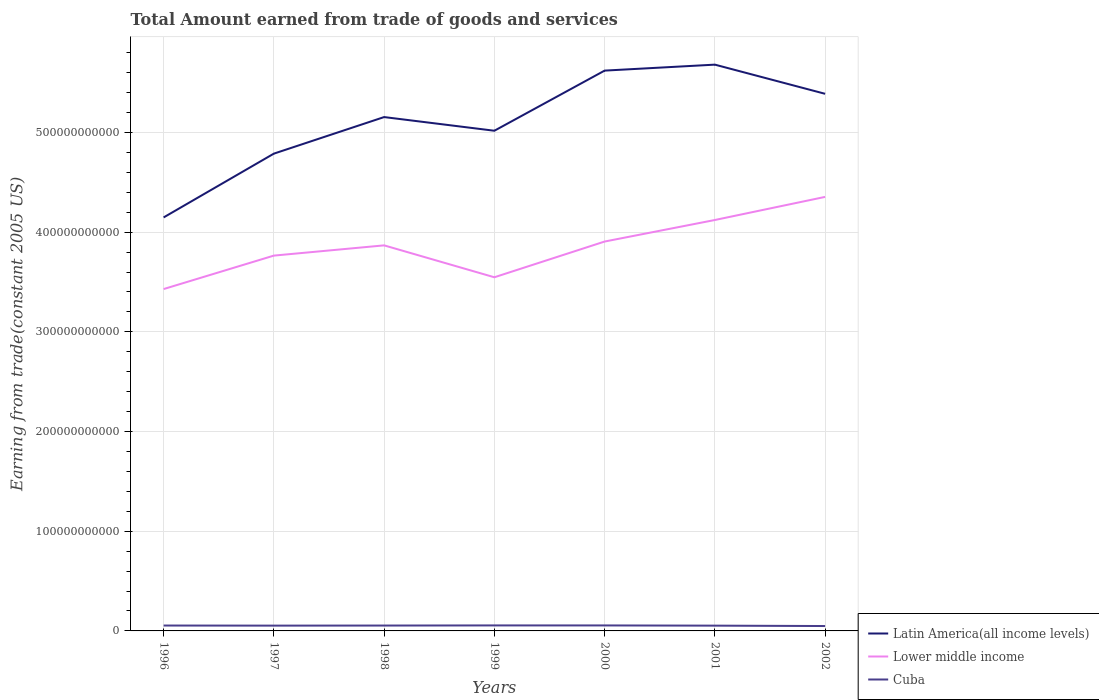How many different coloured lines are there?
Provide a succinct answer. 3. Does the line corresponding to Lower middle income intersect with the line corresponding to Cuba?
Keep it short and to the point. No. Is the number of lines equal to the number of legend labels?
Your answer should be very brief. Yes. Across all years, what is the maximum total amount earned by trading goods and services in Cuba?
Your answer should be compact. 4.91e+09. In which year was the total amount earned by trading goods and services in Lower middle income maximum?
Offer a very short reply. 1996. What is the total total amount earned by trading goods and services in Cuba in the graph?
Provide a short and direct response. 5.93e+08. What is the difference between the highest and the second highest total amount earned by trading goods and services in Lower middle income?
Your answer should be very brief. 9.25e+1. How many lines are there?
Provide a succinct answer. 3. How many years are there in the graph?
Provide a short and direct response. 7. What is the difference between two consecutive major ticks on the Y-axis?
Provide a succinct answer. 1.00e+11. Are the values on the major ticks of Y-axis written in scientific E-notation?
Provide a short and direct response. No. Does the graph contain grids?
Provide a short and direct response. Yes. Where does the legend appear in the graph?
Your answer should be very brief. Bottom right. How many legend labels are there?
Your answer should be compact. 3. How are the legend labels stacked?
Your answer should be compact. Vertical. What is the title of the graph?
Your response must be concise. Total Amount earned from trade of goods and services. What is the label or title of the Y-axis?
Your response must be concise. Earning from trade(constant 2005 US). What is the Earning from trade(constant 2005 US) of Latin America(all income levels) in 1996?
Your response must be concise. 4.15e+11. What is the Earning from trade(constant 2005 US) in Lower middle income in 1996?
Provide a short and direct response. 3.43e+11. What is the Earning from trade(constant 2005 US) in Cuba in 1996?
Offer a terse response. 5.41e+09. What is the Earning from trade(constant 2005 US) of Latin America(all income levels) in 1997?
Offer a terse response. 4.79e+11. What is the Earning from trade(constant 2005 US) of Lower middle income in 1997?
Give a very brief answer. 3.76e+11. What is the Earning from trade(constant 2005 US) of Cuba in 1997?
Give a very brief answer. 5.31e+09. What is the Earning from trade(constant 2005 US) of Latin America(all income levels) in 1998?
Make the answer very short. 5.15e+11. What is the Earning from trade(constant 2005 US) in Lower middle income in 1998?
Your answer should be compact. 3.87e+11. What is the Earning from trade(constant 2005 US) in Cuba in 1998?
Offer a very short reply. 5.38e+09. What is the Earning from trade(constant 2005 US) in Latin America(all income levels) in 1999?
Your answer should be compact. 5.02e+11. What is the Earning from trade(constant 2005 US) in Lower middle income in 1999?
Offer a very short reply. 3.55e+11. What is the Earning from trade(constant 2005 US) of Cuba in 1999?
Your answer should be compact. 5.52e+09. What is the Earning from trade(constant 2005 US) of Latin America(all income levels) in 2000?
Keep it short and to the point. 5.62e+11. What is the Earning from trade(constant 2005 US) of Lower middle income in 2000?
Your answer should be very brief. 3.91e+11. What is the Earning from trade(constant 2005 US) in Cuba in 2000?
Offer a very short reply. 5.50e+09. What is the Earning from trade(constant 2005 US) in Latin America(all income levels) in 2001?
Provide a short and direct response. 5.68e+11. What is the Earning from trade(constant 2005 US) of Lower middle income in 2001?
Keep it short and to the point. 4.12e+11. What is the Earning from trade(constant 2005 US) of Cuba in 2001?
Your answer should be very brief. 5.30e+09. What is the Earning from trade(constant 2005 US) of Latin America(all income levels) in 2002?
Your answer should be compact. 5.39e+11. What is the Earning from trade(constant 2005 US) of Lower middle income in 2002?
Ensure brevity in your answer.  4.35e+11. What is the Earning from trade(constant 2005 US) in Cuba in 2002?
Offer a very short reply. 4.91e+09. Across all years, what is the maximum Earning from trade(constant 2005 US) of Latin America(all income levels)?
Offer a terse response. 5.68e+11. Across all years, what is the maximum Earning from trade(constant 2005 US) in Lower middle income?
Provide a short and direct response. 4.35e+11. Across all years, what is the maximum Earning from trade(constant 2005 US) of Cuba?
Make the answer very short. 5.52e+09. Across all years, what is the minimum Earning from trade(constant 2005 US) in Latin America(all income levels)?
Provide a succinct answer. 4.15e+11. Across all years, what is the minimum Earning from trade(constant 2005 US) of Lower middle income?
Make the answer very short. 3.43e+11. Across all years, what is the minimum Earning from trade(constant 2005 US) in Cuba?
Offer a very short reply. 4.91e+09. What is the total Earning from trade(constant 2005 US) in Latin America(all income levels) in the graph?
Your response must be concise. 3.58e+12. What is the total Earning from trade(constant 2005 US) in Lower middle income in the graph?
Keep it short and to the point. 2.70e+12. What is the total Earning from trade(constant 2005 US) of Cuba in the graph?
Your response must be concise. 3.73e+1. What is the difference between the Earning from trade(constant 2005 US) of Latin America(all income levels) in 1996 and that in 1997?
Your response must be concise. -6.40e+1. What is the difference between the Earning from trade(constant 2005 US) in Lower middle income in 1996 and that in 1997?
Your answer should be very brief. -3.36e+1. What is the difference between the Earning from trade(constant 2005 US) in Cuba in 1996 and that in 1997?
Provide a succinct answer. 1.01e+08. What is the difference between the Earning from trade(constant 2005 US) in Latin America(all income levels) in 1996 and that in 1998?
Ensure brevity in your answer.  -1.01e+11. What is the difference between the Earning from trade(constant 2005 US) of Lower middle income in 1996 and that in 1998?
Keep it short and to the point. -4.38e+1. What is the difference between the Earning from trade(constant 2005 US) of Cuba in 1996 and that in 1998?
Your response must be concise. 2.77e+07. What is the difference between the Earning from trade(constant 2005 US) of Latin America(all income levels) in 1996 and that in 1999?
Provide a succinct answer. -8.70e+1. What is the difference between the Earning from trade(constant 2005 US) of Lower middle income in 1996 and that in 1999?
Your answer should be compact. -1.18e+1. What is the difference between the Earning from trade(constant 2005 US) in Cuba in 1996 and that in 1999?
Keep it short and to the point. -1.03e+08. What is the difference between the Earning from trade(constant 2005 US) of Latin America(all income levels) in 1996 and that in 2000?
Provide a short and direct response. -1.47e+11. What is the difference between the Earning from trade(constant 2005 US) of Lower middle income in 1996 and that in 2000?
Offer a very short reply. -4.77e+1. What is the difference between the Earning from trade(constant 2005 US) in Cuba in 1996 and that in 2000?
Give a very brief answer. -9.10e+07. What is the difference between the Earning from trade(constant 2005 US) in Latin America(all income levels) in 1996 and that in 2001?
Your answer should be compact. -1.53e+11. What is the difference between the Earning from trade(constant 2005 US) in Lower middle income in 1996 and that in 2001?
Ensure brevity in your answer.  -6.93e+1. What is the difference between the Earning from trade(constant 2005 US) of Cuba in 1996 and that in 2001?
Give a very brief answer. 1.16e+08. What is the difference between the Earning from trade(constant 2005 US) of Latin America(all income levels) in 1996 and that in 2002?
Keep it short and to the point. -1.24e+11. What is the difference between the Earning from trade(constant 2005 US) in Lower middle income in 1996 and that in 2002?
Provide a succinct answer. -9.25e+1. What is the difference between the Earning from trade(constant 2005 US) in Cuba in 1996 and that in 2002?
Provide a succinct answer. 5.02e+08. What is the difference between the Earning from trade(constant 2005 US) in Latin America(all income levels) in 1997 and that in 1998?
Ensure brevity in your answer.  -3.67e+1. What is the difference between the Earning from trade(constant 2005 US) in Lower middle income in 1997 and that in 1998?
Give a very brief answer. -1.03e+1. What is the difference between the Earning from trade(constant 2005 US) of Cuba in 1997 and that in 1998?
Offer a terse response. -7.29e+07. What is the difference between the Earning from trade(constant 2005 US) of Latin America(all income levels) in 1997 and that in 1999?
Offer a very short reply. -2.30e+1. What is the difference between the Earning from trade(constant 2005 US) of Lower middle income in 1997 and that in 1999?
Offer a very short reply. 2.17e+1. What is the difference between the Earning from trade(constant 2005 US) in Cuba in 1997 and that in 1999?
Make the answer very short. -2.04e+08. What is the difference between the Earning from trade(constant 2005 US) in Latin America(all income levels) in 1997 and that in 2000?
Give a very brief answer. -8.33e+1. What is the difference between the Earning from trade(constant 2005 US) of Lower middle income in 1997 and that in 2000?
Give a very brief answer. -1.41e+1. What is the difference between the Earning from trade(constant 2005 US) in Cuba in 1997 and that in 2000?
Ensure brevity in your answer.  -1.92e+08. What is the difference between the Earning from trade(constant 2005 US) in Latin America(all income levels) in 1997 and that in 2001?
Give a very brief answer. -8.93e+1. What is the difference between the Earning from trade(constant 2005 US) in Lower middle income in 1997 and that in 2001?
Give a very brief answer. -3.57e+1. What is the difference between the Earning from trade(constant 2005 US) of Cuba in 1997 and that in 2001?
Your response must be concise. 1.49e+07. What is the difference between the Earning from trade(constant 2005 US) in Latin America(all income levels) in 1997 and that in 2002?
Provide a succinct answer. -6.00e+1. What is the difference between the Earning from trade(constant 2005 US) in Lower middle income in 1997 and that in 2002?
Your response must be concise. -5.89e+1. What is the difference between the Earning from trade(constant 2005 US) of Cuba in 1997 and that in 2002?
Provide a short and direct response. 4.02e+08. What is the difference between the Earning from trade(constant 2005 US) in Latin America(all income levels) in 1998 and that in 1999?
Keep it short and to the point. 1.37e+1. What is the difference between the Earning from trade(constant 2005 US) in Lower middle income in 1998 and that in 1999?
Give a very brief answer. 3.20e+1. What is the difference between the Earning from trade(constant 2005 US) of Cuba in 1998 and that in 1999?
Your response must be concise. -1.31e+08. What is the difference between the Earning from trade(constant 2005 US) of Latin America(all income levels) in 1998 and that in 2000?
Ensure brevity in your answer.  -4.66e+1. What is the difference between the Earning from trade(constant 2005 US) of Lower middle income in 1998 and that in 2000?
Offer a very short reply. -3.84e+09. What is the difference between the Earning from trade(constant 2005 US) of Cuba in 1998 and that in 2000?
Ensure brevity in your answer.  -1.19e+08. What is the difference between the Earning from trade(constant 2005 US) in Latin America(all income levels) in 1998 and that in 2001?
Your response must be concise. -5.26e+1. What is the difference between the Earning from trade(constant 2005 US) in Lower middle income in 1998 and that in 2001?
Your answer should be compact. -2.55e+1. What is the difference between the Earning from trade(constant 2005 US) of Cuba in 1998 and that in 2001?
Give a very brief answer. 8.78e+07. What is the difference between the Earning from trade(constant 2005 US) in Latin America(all income levels) in 1998 and that in 2002?
Make the answer very short. -2.33e+1. What is the difference between the Earning from trade(constant 2005 US) in Lower middle income in 1998 and that in 2002?
Your response must be concise. -4.86e+1. What is the difference between the Earning from trade(constant 2005 US) in Cuba in 1998 and that in 2002?
Provide a short and direct response. 4.75e+08. What is the difference between the Earning from trade(constant 2005 US) in Latin America(all income levels) in 1999 and that in 2000?
Your answer should be very brief. -6.03e+1. What is the difference between the Earning from trade(constant 2005 US) of Lower middle income in 1999 and that in 2000?
Make the answer very short. -3.58e+1. What is the difference between the Earning from trade(constant 2005 US) of Cuba in 1999 and that in 2000?
Offer a terse response. 1.22e+07. What is the difference between the Earning from trade(constant 2005 US) in Latin America(all income levels) in 1999 and that in 2001?
Offer a terse response. -6.63e+1. What is the difference between the Earning from trade(constant 2005 US) in Lower middle income in 1999 and that in 2001?
Your response must be concise. -5.74e+1. What is the difference between the Earning from trade(constant 2005 US) of Cuba in 1999 and that in 2001?
Offer a very short reply. 2.19e+08. What is the difference between the Earning from trade(constant 2005 US) of Latin America(all income levels) in 1999 and that in 2002?
Provide a short and direct response. -3.71e+1. What is the difference between the Earning from trade(constant 2005 US) of Lower middle income in 1999 and that in 2002?
Your answer should be compact. -8.06e+1. What is the difference between the Earning from trade(constant 2005 US) of Cuba in 1999 and that in 2002?
Ensure brevity in your answer.  6.05e+08. What is the difference between the Earning from trade(constant 2005 US) in Latin America(all income levels) in 2000 and that in 2001?
Offer a very short reply. -5.99e+09. What is the difference between the Earning from trade(constant 2005 US) of Lower middle income in 2000 and that in 2001?
Provide a succinct answer. -2.16e+1. What is the difference between the Earning from trade(constant 2005 US) of Cuba in 2000 and that in 2001?
Provide a short and direct response. 2.07e+08. What is the difference between the Earning from trade(constant 2005 US) of Latin America(all income levels) in 2000 and that in 2002?
Make the answer very short. 2.33e+1. What is the difference between the Earning from trade(constant 2005 US) in Lower middle income in 2000 and that in 2002?
Offer a terse response. -4.48e+1. What is the difference between the Earning from trade(constant 2005 US) in Cuba in 2000 and that in 2002?
Offer a terse response. 5.93e+08. What is the difference between the Earning from trade(constant 2005 US) of Latin America(all income levels) in 2001 and that in 2002?
Offer a very short reply. 2.93e+1. What is the difference between the Earning from trade(constant 2005 US) in Lower middle income in 2001 and that in 2002?
Ensure brevity in your answer.  -2.32e+1. What is the difference between the Earning from trade(constant 2005 US) of Cuba in 2001 and that in 2002?
Provide a short and direct response. 3.87e+08. What is the difference between the Earning from trade(constant 2005 US) of Latin America(all income levels) in 1996 and the Earning from trade(constant 2005 US) of Lower middle income in 1997?
Your answer should be very brief. 3.83e+1. What is the difference between the Earning from trade(constant 2005 US) of Latin America(all income levels) in 1996 and the Earning from trade(constant 2005 US) of Cuba in 1997?
Keep it short and to the point. 4.09e+11. What is the difference between the Earning from trade(constant 2005 US) in Lower middle income in 1996 and the Earning from trade(constant 2005 US) in Cuba in 1997?
Provide a succinct answer. 3.38e+11. What is the difference between the Earning from trade(constant 2005 US) in Latin America(all income levels) in 1996 and the Earning from trade(constant 2005 US) in Lower middle income in 1998?
Your answer should be compact. 2.80e+1. What is the difference between the Earning from trade(constant 2005 US) of Latin America(all income levels) in 1996 and the Earning from trade(constant 2005 US) of Cuba in 1998?
Offer a very short reply. 4.09e+11. What is the difference between the Earning from trade(constant 2005 US) in Lower middle income in 1996 and the Earning from trade(constant 2005 US) in Cuba in 1998?
Keep it short and to the point. 3.38e+11. What is the difference between the Earning from trade(constant 2005 US) in Latin America(all income levels) in 1996 and the Earning from trade(constant 2005 US) in Lower middle income in 1999?
Offer a very short reply. 6.00e+1. What is the difference between the Earning from trade(constant 2005 US) in Latin America(all income levels) in 1996 and the Earning from trade(constant 2005 US) in Cuba in 1999?
Provide a short and direct response. 4.09e+11. What is the difference between the Earning from trade(constant 2005 US) in Lower middle income in 1996 and the Earning from trade(constant 2005 US) in Cuba in 1999?
Provide a succinct answer. 3.37e+11. What is the difference between the Earning from trade(constant 2005 US) of Latin America(all income levels) in 1996 and the Earning from trade(constant 2005 US) of Lower middle income in 2000?
Keep it short and to the point. 2.42e+1. What is the difference between the Earning from trade(constant 2005 US) in Latin America(all income levels) in 1996 and the Earning from trade(constant 2005 US) in Cuba in 2000?
Your response must be concise. 4.09e+11. What is the difference between the Earning from trade(constant 2005 US) of Lower middle income in 1996 and the Earning from trade(constant 2005 US) of Cuba in 2000?
Provide a short and direct response. 3.37e+11. What is the difference between the Earning from trade(constant 2005 US) in Latin America(all income levels) in 1996 and the Earning from trade(constant 2005 US) in Lower middle income in 2001?
Provide a succinct answer. 2.57e+09. What is the difference between the Earning from trade(constant 2005 US) of Latin America(all income levels) in 1996 and the Earning from trade(constant 2005 US) of Cuba in 2001?
Your answer should be very brief. 4.09e+11. What is the difference between the Earning from trade(constant 2005 US) of Lower middle income in 1996 and the Earning from trade(constant 2005 US) of Cuba in 2001?
Give a very brief answer. 3.38e+11. What is the difference between the Earning from trade(constant 2005 US) in Latin America(all income levels) in 1996 and the Earning from trade(constant 2005 US) in Lower middle income in 2002?
Give a very brief answer. -2.06e+1. What is the difference between the Earning from trade(constant 2005 US) of Latin America(all income levels) in 1996 and the Earning from trade(constant 2005 US) of Cuba in 2002?
Give a very brief answer. 4.10e+11. What is the difference between the Earning from trade(constant 2005 US) of Lower middle income in 1996 and the Earning from trade(constant 2005 US) of Cuba in 2002?
Ensure brevity in your answer.  3.38e+11. What is the difference between the Earning from trade(constant 2005 US) of Latin America(all income levels) in 1997 and the Earning from trade(constant 2005 US) of Lower middle income in 1998?
Provide a short and direct response. 9.20e+1. What is the difference between the Earning from trade(constant 2005 US) of Latin America(all income levels) in 1997 and the Earning from trade(constant 2005 US) of Cuba in 1998?
Give a very brief answer. 4.73e+11. What is the difference between the Earning from trade(constant 2005 US) in Lower middle income in 1997 and the Earning from trade(constant 2005 US) in Cuba in 1998?
Make the answer very short. 3.71e+11. What is the difference between the Earning from trade(constant 2005 US) in Latin America(all income levels) in 1997 and the Earning from trade(constant 2005 US) in Lower middle income in 1999?
Offer a very short reply. 1.24e+11. What is the difference between the Earning from trade(constant 2005 US) of Latin America(all income levels) in 1997 and the Earning from trade(constant 2005 US) of Cuba in 1999?
Ensure brevity in your answer.  4.73e+11. What is the difference between the Earning from trade(constant 2005 US) of Lower middle income in 1997 and the Earning from trade(constant 2005 US) of Cuba in 1999?
Give a very brief answer. 3.71e+11. What is the difference between the Earning from trade(constant 2005 US) in Latin America(all income levels) in 1997 and the Earning from trade(constant 2005 US) in Lower middle income in 2000?
Keep it short and to the point. 8.82e+1. What is the difference between the Earning from trade(constant 2005 US) in Latin America(all income levels) in 1997 and the Earning from trade(constant 2005 US) in Cuba in 2000?
Give a very brief answer. 4.73e+11. What is the difference between the Earning from trade(constant 2005 US) of Lower middle income in 1997 and the Earning from trade(constant 2005 US) of Cuba in 2000?
Make the answer very short. 3.71e+11. What is the difference between the Earning from trade(constant 2005 US) in Latin America(all income levels) in 1997 and the Earning from trade(constant 2005 US) in Lower middle income in 2001?
Provide a short and direct response. 6.66e+1. What is the difference between the Earning from trade(constant 2005 US) in Latin America(all income levels) in 1997 and the Earning from trade(constant 2005 US) in Cuba in 2001?
Provide a short and direct response. 4.73e+11. What is the difference between the Earning from trade(constant 2005 US) in Lower middle income in 1997 and the Earning from trade(constant 2005 US) in Cuba in 2001?
Offer a very short reply. 3.71e+11. What is the difference between the Earning from trade(constant 2005 US) of Latin America(all income levels) in 1997 and the Earning from trade(constant 2005 US) of Lower middle income in 2002?
Provide a succinct answer. 4.34e+1. What is the difference between the Earning from trade(constant 2005 US) in Latin America(all income levels) in 1997 and the Earning from trade(constant 2005 US) in Cuba in 2002?
Your answer should be very brief. 4.74e+11. What is the difference between the Earning from trade(constant 2005 US) of Lower middle income in 1997 and the Earning from trade(constant 2005 US) of Cuba in 2002?
Make the answer very short. 3.72e+11. What is the difference between the Earning from trade(constant 2005 US) in Latin America(all income levels) in 1998 and the Earning from trade(constant 2005 US) in Lower middle income in 1999?
Give a very brief answer. 1.61e+11. What is the difference between the Earning from trade(constant 2005 US) of Latin America(all income levels) in 1998 and the Earning from trade(constant 2005 US) of Cuba in 1999?
Ensure brevity in your answer.  5.10e+11. What is the difference between the Earning from trade(constant 2005 US) of Lower middle income in 1998 and the Earning from trade(constant 2005 US) of Cuba in 1999?
Your answer should be very brief. 3.81e+11. What is the difference between the Earning from trade(constant 2005 US) of Latin America(all income levels) in 1998 and the Earning from trade(constant 2005 US) of Lower middle income in 2000?
Keep it short and to the point. 1.25e+11. What is the difference between the Earning from trade(constant 2005 US) in Latin America(all income levels) in 1998 and the Earning from trade(constant 2005 US) in Cuba in 2000?
Your response must be concise. 5.10e+11. What is the difference between the Earning from trade(constant 2005 US) of Lower middle income in 1998 and the Earning from trade(constant 2005 US) of Cuba in 2000?
Provide a succinct answer. 3.81e+11. What is the difference between the Earning from trade(constant 2005 US) of Latin America(all income levels) in 1998 and the Earning from trade(constant 2005 US) of Lower middle income in 2001?
Give a very brief answer. 1.03e+11. What is the difference between the Earning from trade(constant 2005 US) of Latin America(all income levels) in 1998 and the Earning from trade(constant 2005 US) of Cuba in 2001?
Keep it short and to the point. 5.10e+11. What is the difference between the Earning from trade(constant 2005 US) of Lower middle income in 1998 and the Earning from trade(constant 2005 US) of Cuba in 2001?
Give a very brief answer. 3.81e+11. What is the difference between the Earning from trade(constant 2005 US) of Latin America(all income levels) in 1998 and the Earning from trade(constant 2005 US) of Lower middle income in 2002?
Provide a succinct answer. 8.01e+1. What is the difference between the Earning from trade(constant 2005 US) in Latin America(all income levels) in 1998 and the Earning from trade(constant 2005 US) in Cuba in 2002?
Your answer should be compact. 5.11e+11. What is the difference between the Earning from trade(constant 2005 US) of Lower middle income in 1998 and the Earning from trade(constant 2005 US) of Cuba in 2002?
Keep it short and to the point. 3.82e+11. What is the difference between the Earning from trade(constant 2005 US) of Latin America(all income levels) in 1999 and the Earning from trade(constant 2005 US) of Lower middle income in 2000?
Your response must be concise. 1.11e+11. What is the difference between the Earning from trade(constant 2005 US) of Latin America(all income levels) in 1999 and the Earning from trade(constant 2005 US) of Cuba in 2000?
Provide a succinct answer. 4.96e+11. What is the difference between the Earning from trade(constant 2005 US) in Lower middle income in 1999 and the Earning from trade(constant 2005 US) in Cuba in 2000?
Offer a terse response. 3.49e+11. What is the difference between the Earning from trade(constant 2005 US) of Latin America(all income levels) in 1999 and the Earning from trade(constant 2005 US) of Lower middle income in 2001?
Ensure brevity in your answer.  8.95e+1. What is the difference between the Earning from trade(constant 2005 US) of Latin America(all income levels) in 1999 and the Earning from trade(constant 2005 US) of Cuba in 2001?
Your answer should be very brief. 4.96e+11. What is the difference between the Earning from trade(constant 2005 US) of Lower middle income in 1999 and the Earning from trade(constant 2005 US) of Cuba in 2001?
Keep it short and to the point. 3.49e+11. What is the difference between the Earning from trade(constant 2005 US) in Latin America(all income levels) in 1999 and the Earning from trade(constant 2005 US) in Lower middle income in 2002?
Your answer should be compact. 6.64e+1. What is the difference between the Earning from trade(constant 2005 US) of Latin America(all income levels) in 1999 and the Earning from trade(constant 2005 US) of Cuba in 2002?
Make the answer very short. 4.97e+11. What is the difference between the Earning from trade(constant 2005 US) of Lower middle income in 1999 and the Earning from trade(constant 2005 US) of Cuba in 2002?
Offer a very short reply. 3.50e+11. What is the difference between the Earning from trade(constant 2005 US) of Latin America(all income levels) in 2000 and the Earning from trade(constant 2005 US) of Lower middle income in 2001?
Keep it short and to the point. 1.50e+11. What is the difference between the Earning from trade(constant 2005 US) in Latin America(all income levels) in 2000 and the Earning from trade(constant 2005 US) in Cuba in 2001?
Provide a succinct answer. 5.57e+11. What is the difference between the Earning from trade(constant 2005 US) in Lower middle income in 2000 and the Earning from trade(constant 2005 US) in Cuba in 2001?
Give a very brief answer. 3.85e+11. What is the difference between the Earning from trade(constant 2005 US) of Latin America(all income levels) in 2000 and the Earning from trade(constant 2005 US) of Lower middle income in 2002?
Keep it short and to the point. 1.27e+11. What is the difference between the Earning from trade(constant 2005 US) in Latin America(all income levels) in 2000 and the Earning from trade(constant 2005 US) in Cuba in 2002?
Make the answer very short. 5.57e+11. What is the difference between the Earning from trade(constant 2005 US) in Lower middle income in 2000 and the Earning from trade(constant 2005 US) in Cuba in 2002?
Your response must be concise. 3.86e+11. What is the difference between the Earning from trade(constant 2005 US) in Latin America(all income levels) in 2001 and the Earning from trade(constant 2005 US) in Lower middle income in 2002?
Offer a very short reply. 1.33e+11. What is the difference between the Earning from trade(constant 2005 US) of Latin America(all income levels) in 2001 and the Earning from trade(constant 2005 US) of Cuba in 2002?
Offer a terse response. 5.63e+11. What is the difference between the Earning from trade(constant 2005 US) of Lower middle income in 2001 and the Earning from trade(constant 2005 US) of Cuba in 2002?
Ensure brevity in your answer.  4.07e+11. What is the average Earning from trade(constant 2005 US) of Latin America(all income levels) per year?
Offer a very short reply. 5.11e+11. What is the average Earning from trade(constant 2005 US) in Lower middle income per year?
Provide a succinct answer. 3.86e+11. What is the average Earning from trade(constant 2005 US) in Cuba per year?
Give a very brief answer. 5.33e+09. In the year 1996, what is the difference between the Earning from trade(constant 2005 US) in Latin America(all income levels) and Earning from trade(constant 2005 US) in Lower middle income?
Provide a short and direct response. 7.19e+1. In the year 1996, what is the difference between the Earning from trade(constant 2005 US) in Latin America(all income levels) and Earning from trade(constant 2005 US) in Cuba?
Your answer should be compact. 4.09e+11. In the year 1996, what is the difference between the Earning from trade(constant 2005 US) of Lower middle income and Earning from trade(constant 2005 US) of Cuba?
Make the answer very short. 3.38e+11. In the year 1997, what is the difference between the Earning from trade(constant 2005 US) in Latin America(all income levels) and Earning from trade(constant 2005 US) in Lower middle income?
Provide a succinct answer. 1.02e+11. In the year 1997, what is the difference between the Earning from trade(constant 2005 US) in Latin America(all income levels) and Earning from trade(constant 2005 US) in Cuba?
Your response must be concise. 4.73e+11. In the year 1997, what is the difference between the Earning from trade(constant 2005 US) in Lower middle income and Earning from trade(constant 2005 US) in Cuba?
Keep it short and to the point. 3.71e+11. In the year 1998, what is the difference between the Earning from trade(constant 2005 US) of Latin America(all income levels) and Earning from trade(constant 2005 US) of Lower middle income?
Your response must be concise. 1.29e+11. In the year 1998, what is the difference between the Earning from trade(constant 2005 US) of Latin America(all income levels) and Earning from trade(constant 2005 US) of Cuba?
Offer a very short reply. 5.10e+11. In the year 1998, what is the difference between the Earning from trade(constant 2005 US) in Lower middle income and Earning from trade(constant 2005 US) in Cuba?
Offer a terse response. 3.81e+11. In the year 1999, what is the difference between the Earning from trade(constant 2005 US) of Latin America(all income levels) and Earning from trade(constant 2005 US) of Lower middle income?
Provide a succinct answer. 1.47e+11. In the year 1999, what is the difference between the Earning from trade(constant 2005 US) of Latin America(all income levels) and Earning from trade(constant 2005 US) of Cuba?
Keep it short and to the point. 4.96e+11. In the year 1999, what is the difference between the Earning from trade(constant 2005 US) in Lower middle income and Earning from trade(constant 2005 US) in Cuba?
Your answer should be compact. 3.49e+11. In the year 2000, what is the difference between the Earning from trade(constant 2005 US) in Latin America(all income levels) and Earning from trade(constant 2005 US) in Lower middle income?
Give a very brief answer. 1.71e+11. In the year 2000, what is the difference between the Earning from trade(constant 2005 US) in Latin America(all income levels) and Earning from trade(constant 2005 US) in Cuba?
Your answer should be compact. 5.57e+11. In the year 2000, what is the difference between the Earning from trade(constant 2005 US) in Lower middle income and Earning from trade(constant 2005 US) in Cuba?
Keep it short and to the point. 3.85e+11. In the year 2001, what is the difference between the Earning from trade(constant 2005 US) of Latin America(all income levels) and Earning from trade(constant 2005 US) of Lower middle income?
Your response must be concise. 1.56e+11. In the year 2001, what is the difference between the Earning from trade(constant 2005 US) of Latin America(all income levels) and Earning from trade(constant 2005 US) of Cuba?
Give a very brief answer. 5.63e+11. In the year 2001, what is the difference between the Earning from trade(constant 2005 US) in Lower middle income and Earning from trade(constant 2005 US) in Cuba?
Offer a terse response. 4.07e+11. In the year 2002, what is the difference between the Earning from trade(constant 2005 US) of Latin America(all income levels) and Earning from trade(constant 2005 US) of Lower middle income?
Your answer should be very brief. 1.03e+11. In the year 2002, what is the difference between the Earning from trade(constant 2005 US) in Latin America(all income levels) and Earning from trade(constant 2005 US) in Cuba?
Ensure brevity in your answer.  5.34e+11. In the year 2002, what is the difference between the Earning from trade(constant 2005 US) in Lower middle income and Earning from trade(constant 2005 US) in Cuba?
Ensure brevity in your answer.  4.30e+11. What is the ratio of the Earning from trade(constant 2005 US) of Latin America(all income levels) in 1996 to that in 1997?
Offer a terse response. 0.87. What is the ratio of the Earning from trade(constant 2005 US) of Lower middle income in 1996 to that in 1997?
Offer a very short reply. 0.91. What is the ratio of the Earning from trade(constant 2005 US) of Cuba in 1996 to that in 1997?
Your answer should be very brief. 1.02. What is the ratio of the Earning from trade(constant 2005 US) of Latin America(all income levels) in 1996 to that in 1998?
Make the answer very short. 0.8. What is the ratio of the Earning from trade(constant 2005 US) in Lower middle income in 1996 to that in 1998?
Your response must be concise. 0.89. What is the ratio of the Earning from trade(constant 2005 US) in Latin America(all income levels) in 1996 to that in 1999?
Give a very brief answer. 0.83. What is the ratio of the Earning from trade(constant 2005 US) of Lower middle income in 1996 to that in 1999?
Provide a short and direct response. 0.97. What is the ratio of the Earning from trade(constant 2005 US) in Cuba in 1996 to that in 1999?
Your answer should be very brief. 0.98. What is the ratio of the Earning from trade(constant 2005 US) in Latin America(all income levels) in 1996 to that in 2000?
Offer a terse response. 0.74. What is the ratio of the Earning from trade(constant 2005 US) of Lower middle income in 1996 to that in 2000?
Keep it short and to the point. 0.88. What is the ratio of the Earning from trade(constant 2005 US) of Cuba in 1996 to that in 2000?
Provide a succinct answer. 0.98. What is the ratio of the Earning from trade(constant 2005 US) of Latin America(all income levels) in 1996 to that in 2001?
Your answer should be very brief. 0.73. What is the ratio of the Earning from trade(constant 2005 US) in Lower middle income in 1996 to that in 2001?
Your response must be concise. 0.83. What is the ratio of the Earning from trade(constant 2005 US) in Cuba in 1996 to that in 2001?
Make the answer very short. 1.02. What is the ratio of the Earning from trade(constant 2005 US) in Latin America(all income levels) in 1996 to that in 2002?
Provide a succinct answer. 0.77. What is the ratio of the Earning from trade(constant 2005 US) in Lower middle income in 1996 to that in 2002?
Your answer should be compact. 0.79. What is the ratio of the Earning from trade(constant 2005 US) in Cuba in 1996 to that in 2002?
Offer a terse response. 1.1. What is the ratio of the Earning from trade(constant 2005 US) in Latin America(all income levels) in 1997 to that in 1998?
Provide a succinct answer. 0.93. What is the ratio of the Earning from trade(constant 2005 US) of Lower middle income in 1997 to that in 1998?
Give a very brief answer. 0.97. What is the ratio of the Earning from trade(constant 2005 US) in Cuba in 1997 to that in 1998?
Offer a very short reply. 0.99. What is the ratio of the Earning from trade(constant 2005 US) of Latin America(all income levels) in 1997 to that in 1999?
Your answer should be compact. 0.95. What is the ratio of the Earning from trade(constant 2005 US) in Lower middle income in 1997 to that in 1999?
Offer a terse response. 1.06. What is the ratio of the Earning from trade(constant 2005 US) of Cuba in 1997 to that in 1999?
Offer a terse response. 0.96. What is the ratio of the Earning from trade(constant 2005 US) of Latin America(all income levels) in 1997 to that in 2000?
Provide a succinct answer. 0.85. What is the ratio of the Earning from trade(constant 2005 US) in Lower middle income in 1997 to that in 2000?
Offer a terse response. 0.96. What is the ratio of the Earning from trade(constant 2005 US) of Cuba in 1997 to that in 2000?
Provide a short and direct response. 0.97. What is the ratio of the Earning from trade(constant 2005 US) of Latin America(all income levels) in 1997 to that in 2001?
Offer a terse response. 0.84. What is the ratio of the Earning from trade(constant 2005 US) in Lower middle income in 1997 to that in 2001?
Your response must be concise. 0.91. What is the ratio of the Earning from trade(constant 2005 US) of Latin America(all income levels) in 1997 to that in 2002?
Offer a terse response. 0.89. What is the ratio of the Earning from trade(constant 2005 US) of Lower middle income in 1997 to that in 2002?
Offer a very short reply. 0.86. What is the ratio of the Earning from trade(constant 2005 US) of Cuba in 1997 to that in 2002?
Your response must be concise. 1.08. What is the ratio of the Earning from trade(constant 2005 US) of Latin America(all income levels) in 1998 to that in 1999?
Your answer should be compact. 1.03. What is the ratio of the Earning from trade(constant 2005 US) of Lower middle income in 1998 to that in 1999?
Provide a succinct answer. 1.09. What is the ratio of the Earning from trade(constant 2005 US) of Cuba in 1998 to that in 1999?
Keep it short and to the point. 0.98. What is the ratio of the Earning from trade(constant 2005 US) in Latin America(all income levels) in 1998 to that in 2000?
Provide a succinct answer. 0.92. What is the ratio of the Earning from trade(constant 2005 US) in Lower middle income in 1998 to that in 2000?
Your response must be concise. 0.99. What is the ratio of the Earning from trade(constant 2005 US) of Cuba in 1998 to that in 2000?
Your response must be concise. 0.98. What is the ratio of the Earning from trade(constant 2005 US) of Latin America(all income levels) in 1998 to that in 2001?
Provide a short and direct response. 0.91. What is the ratio of the Earning from trade(constant 2005 US) in Lower middle income in 1998 to that in 2001?
Your answer should be compact. 0.94. What is the ratio of the Earning from trade(constant 2005 US) in Cuba in 1998 to that in 2001?
Your response must be concise. 1.02. What is the ratio of the Earning from trade(constant 2005 US) of Latin America(all income levels) in 1998 to that in 2002?
Keep it short and to the point. 0.96. What is the ratio of the Earning from trade(constant 2005 US) in Lower middle income in 1998 to that in 2002?
Your answer should be very brief. 0.89. What is the ratio of the Earning from trade(constant 2005 US) of Cuba in 1998 to that in 2002?
Give a very brief answer. 1.1. What is the ratio of the Earning from trade(constant 2005 US) of Latin America(all income levels) in 1999 to that in 2000?
Ensure brevity in your answer.  0.89. What is the ratio of the Earning from trade(constant 2005 US) in Lower middle income in 1999 to that in 2000?
Your answer should be very brief. 0.91. What is the ratio of the Earning from trade(constant 2005 US) in Cuba in 1999 to that in 2000?
Provide a short and direct response. 1. What is the ratio of the Earning from trade(constant 2005 US) in Latin America(all income levels) in 1999 to that in 2001?
Provide a short and direct response. 0.88. What is the ratio of the Earning from trade(constant 2005 US) of Lower middle income in 1999 to that in 2001?
Make the answer very short. 0.86. What is the ratio of the Earning from trade(constant 2005 US) of Cuba in 1999 to that in 2001?
Give a very brief answer. 1.04. What is the ratio of the Earning from trade(constant 2005 US) of Latin America(all income levels) in 1999 to that in 2002?
Make the answer very short. 0.93. What is the ratio of the Earning from trade(constant 2005 US) in Lower middle income in 1999 to that in 2002?
Your response must be concise. 0.81. What is the ratio of the Earning from trade(constant 2005 US) of Cuba in 1999 to that in 2002?
Your response must be concise. 1.12. What is the ratio of the Earning from trade(constant 2005 US) in Latin America(all income levels) in 2000 to that in 2001?
Your answer should be compact. 0.99. What is the ratio of the Earning from trade(constant 2005 US) in Lower middle income in 2000 to that in 2001?
Ensure brevity in your answer.  0.95. What is the ratio of the Earning from trade(constant 2005 US) in Cuba in 2000 to that in 2001?
Your response must be concise. 1.04. What is the ratio of the Earning from trade(constant 2005 US) of Latin America(all income levels) in 2000 to that in 2002?
Provide a succinct answer. 1.04. What is the ratio of the Earning from trade(constant 2005 US) of Lower middle income in 2000 to that in 2002?
Keep it short and to the point. 0.9. What is the ratio of the Earning from trade(constant 2005 US) in Cuba in 2000 to that in 2002?
Your answer should be compact. 1.12. What is the ratio of the Earning from trade(constant 2005 US) of Latin America(all income levels) in 2001 to that in 2002?
Your answer should be very brief. 1.05. What is the ratio of the Earning from trade(constant 2005 US) in Lower middle income in 2001 to that in 2002?
Your answer should be compact. 0.95. What is the ratio of the Earning from trade(constant 2005 US) in Cuba in 2001 to that in 2002?
Provide a succinct answer. 1.08. What is the difference between the highest and the second highest Earning from trade(constant 2005 US) in Latin America(all income levels)?
Offer a terse response. 5.99e+09. What is the difference between the highest and the second highest Earning from trade(constant 2005 US) of Lower middle income?
Give a very brief answer. 2.32e+1. What is the difference between the highest and the second highest Earning from trade(constant 2005 US) of Cuba?
Offer a terse response. 1.22e+07. What is the difference between the highest and the lowest Earning from trade(constant 2005 US) of Latin America(all income levels)?
Your answer should be compact. 1.53e+11. What is the difference between the highest and the lowest Earning from trade(constant 2005 US) in Lower middle income?
Offer a very short reply. 9.25e+1. What is the difference between the highest and the lowest Earning from trade(constant 2005 US) in Cuba?
Provide a succinct answer. 6.05e+08. 